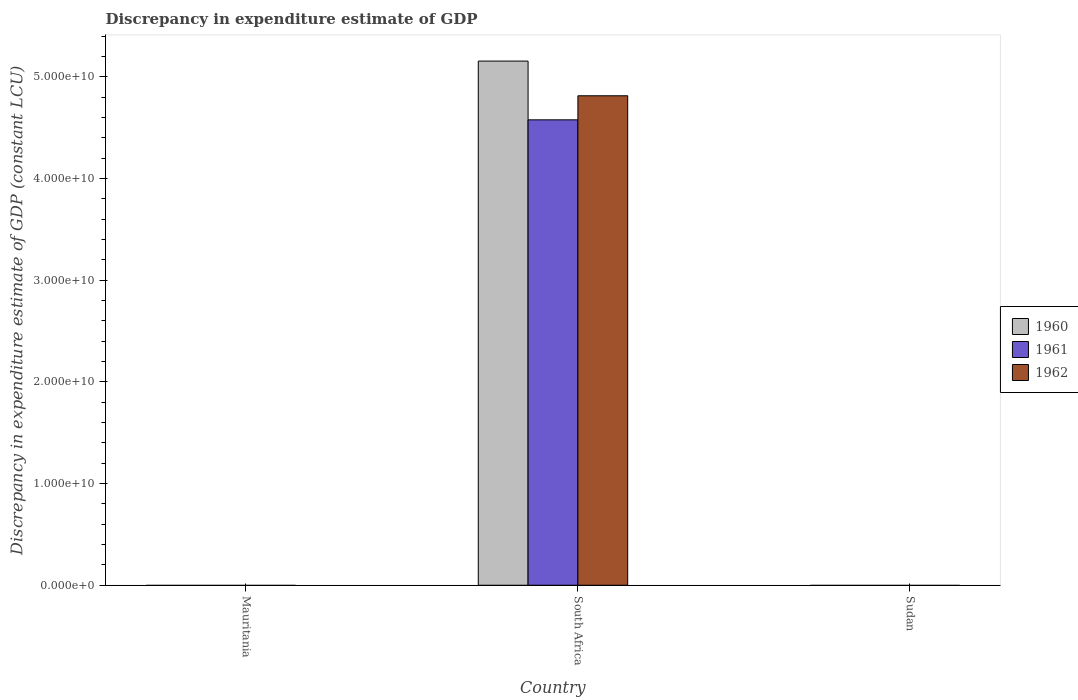How many different coloured bars are there?
Your response must be concise. 3. Are the number of bars per tick equal to the number of legend labels?
Provide a succinct answer. No. Are the number of bars on each tick of the X-axis equal?
Offer a terse response. No. How many bars are there on the 3rd tick from the left?
Provide a short and direct response. 0. What is the label of the 2nd group of bars from the left?
Keep it short and to the point. South Africa. What is the discrepancy in expenditure estimate of GDP in 1961 in South Africa?
Offer a terse response. 4.58e+1. Across all countries, what is the maximum discrepancy in expenditure estimate of GDP in 1962?
Your response must be concise. 4.81e+1. In which country was the discrepancy in expenditure estimate of GDP in 1961 maximum?
Your response must be concise. South Africa. What is the total discrepancy in expenditure estimate of GDP in 1961 in the graph?
Give a very brief answer. 4.58e+1. What is the difference between the discrepancy in expenditure estimate of GDP in 1960 in South Africa and the discrepancy in expenditure estimate of GDP in 1961 in Sudan?
Keep it short and to the point. 5.15e+1. What is the average discrepancy in expenditure estimate of GDP in 1962 per country?
Ensure brevity in your answer.  1.60e+1. What is the difference between the discrepancy in expenditure estimate of GDP of/in 1962 and discrepancy in expenditure estimate of GDP of/in 1960 in South Africa?
Offer a terse response. -3.41e+09. In how many countries, is the discrepancy in expenditure estimate of GDP in 1961 greater than 26000000000 LCU?
Keep it short and to the point. 1. What is the difference between the highest and the lowest discrepancy in expenditure estimate of GDP in 1961?
Your response must be concise. 4.58e+1. Is it the case that in every country, the sum of the discrepancy in expenditure estimate of GDP in 1960 and discrepancy in expenditure estimate of GDP in 1961 is greater than the discrepancy in expenditure estimate of GDP in 1962?
Your answer should be compact. No. How many bars are there?
Keep it short and to the point. 3. Are all the bars in the graph horizontal?
Make the answer very short. No. How many countries are there in the graph?
Make the answer very short. 3. Does the graph contain grids?
Make the answer very short. No. How many legend labels are there?
Give a very brief answer. 3. What is the title of the graph?
Provide a short and direct response. Discrepancy in expenditure estimate of GDP. Does "1974" appear as one of the legend labels in the graph?
Offer a very short reply. No. What is the label or title of the X-axis?
Offer a very short reply. Country. What is the label or title of the Y-axis?
Provide a short and direct response. Discrepancy in expenditure estimate of GDP (constant LCU). What is the Discrepancy in expenditure estimate of GDP (constant LCU) in 1961 in Mauritania?
Your response must be concise. 0. What is the Discrepancy in expenditure estimate of GDP (constant LCU) of 1960 in South Africa?
Make the answer very short. 5.15e+1. What is the Discrepancy in expenditure estimate of GDP (constant LCU) in 1961 in South Africa?
Keep it short and to the point. 4.58e+1. What is the Discrepancy in expenditure estimate of GDP (constant LCU) in 1962 in South Africa?
Ensure brevity in your answer.  4.81e+1. What is the Discrepancy in expenditure estimate of GDP (constant LCU) in 1960 in Sudan?
Make the answer very short. 0. What is the Discrepancy in expenditure estimate of GDP (constant LCU) of 1962 in Sudan?
Offer a very short reply. 0. Across all countries, what is the maximum Discrepancy in expenditure estimate of GDP (constant LCU) in 1960?
Provide a succinct answer. 5.15e+1. Across all countries, what is the maximum Discrepancy in expenditure estimate of GDP (constant LCU) of 1961?
Keep it short and to the point. 4.58e+1. Across all countries, what is the maximum Discrepancy in expenditure estimate of GDP (constant LCU) in 1962?
Give a very brief answer. 4.81e+1. Across all countries, what is the minimum Discrepancy in expenditure estimate of GDP (constant LCU) of 1960?
Offer a very short reply. 0. What is the total Discrepancy in expenditure estimate of GDP (constant LCU) of 1960 in the graph?
Offer a very short reply. 5.15e+1. What is the total Discrepancy in expenditure estimate of GDP (constant LCU) of 1961 in the graph?
Keep it short and to the point. 4.58e+1. What is the total Discrepancy in expenditure estimate of GDP (constant LCU) of 1962 in the graph?
Your answer should be compact. 4.81e+1. What is the average Discrepancy in expenditure estimate of GDP (constant LCU) of 1960 per country?
Make the answer very short. 1.72e+1. What is the average Discrepancy in expenditure estimate of GDP (constant LCU) in 1961 per country?
Offer a very short reply. 1.53e+1. What is the average Discrepancy in expenditure estimate of GDP (constant LCU) of 1962 per country?
Your answer should be compact. 1.60e+1. What is the difference between the Discrepancy in expenditure estimate of GDP (constant LCU) in 1960 and Discrepancy in expenditure estimate of GDP (constant LCU) in 1961 in South Africa?
Offer a terse response. 5.78e+09. What is the difference between the Discrepancy in expenditure estimate of GDP (constant LCU) of 1960 and Discrepancy in expenditure estimate of GDP (constant LCU) of 1962 in South Africa?
Keep it short and to the point. 3.41e+09. What is the difference between the Discrepancy in expenditure estimate of GDP (constant LCU) in 1961 and Discrepancy in expenditure estimate of GDP (constant LCU) in 1962 in South Africa?
Your answer should be compact. -2.37e+09. What is the difference between the highest and the lowest Discrepancy in expenditure estimate of GDP (constant LCU) of 1960?
Provide a succinct answer. 5.15e+1. What is the difference between the highest and the lowest Discrepancy in expenditure estimate of GDP (constant LCU) of 1961?
Your answer should be very brief. 4.58e+1. What is the difference between the highest and the lowest Discrepancy in expenditure estimate of GDP (constant LCU) of 1962?
Ensure brevity in your answer.  4.81e+1. 